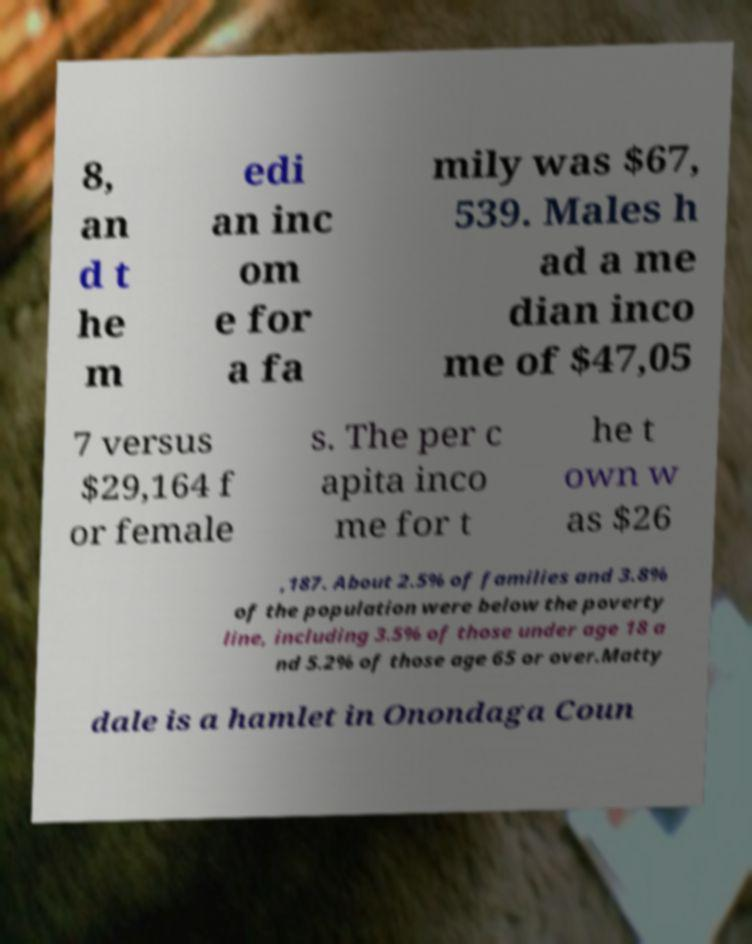Could you extract and type out the text from this image? 8, an d t he m edi an inc om e for a fa mily was $67, 539. Males h ad a me dian inco me of $47,05 7 versus $29,164 f or female s. The per c apita inco me for t he t own w as $26 ,187. About 2.5% of families and 3.8% of the population were below the poverty line, including 3.5% of those under age 18 a nd 5.2% of those age 65 or over.Matty dale is a hamlet in Onondaga Coun 